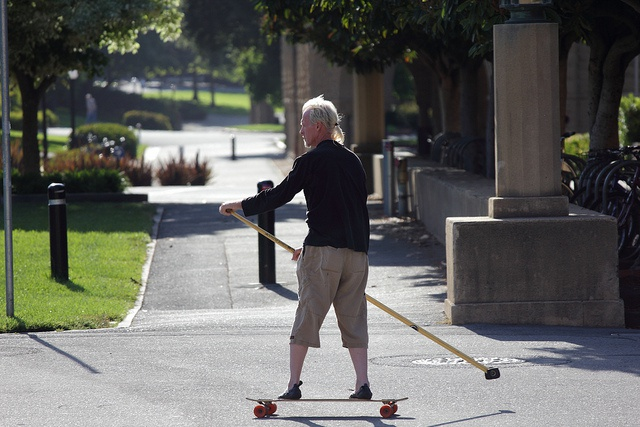Describe the objects in this image and their specific colors. I can see people in darkblue, black, gray, maroon, and lightgray tones, bicycle in darkblue, black, gray, and darkgray tones, and skateboard in darkblue, maroon, gray, darkgray, and black tones in this image. 